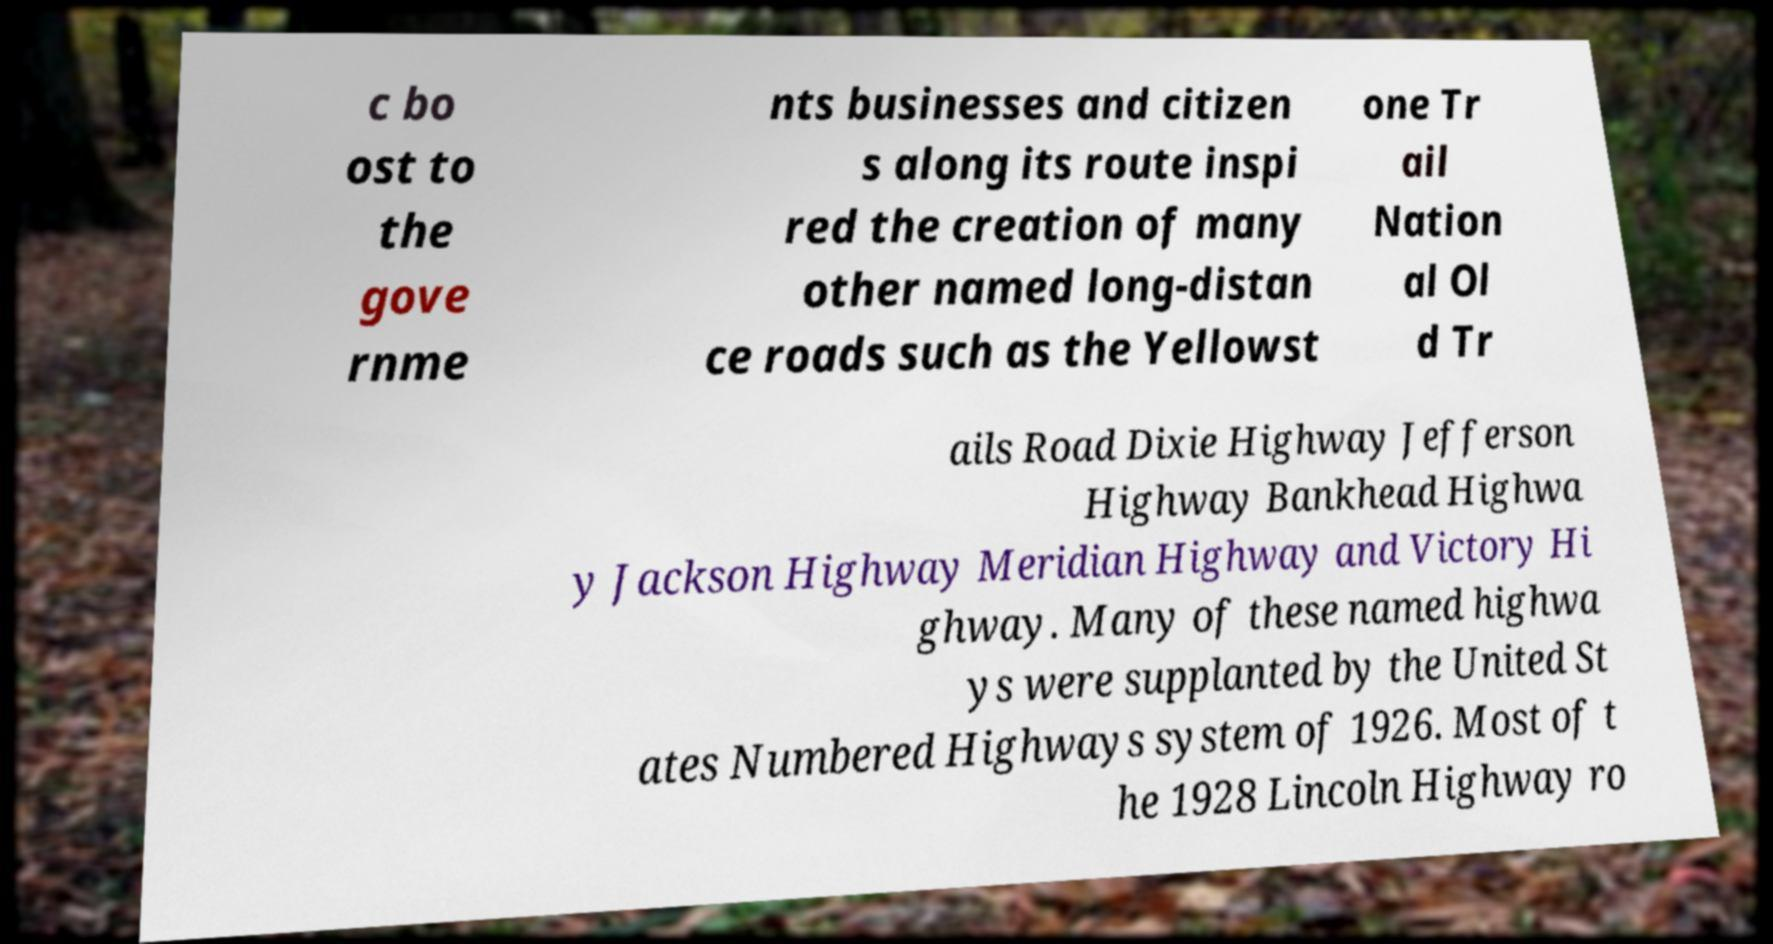Could you extract and type out the text from this image? c bo ost to the gove rnme nts businesses and citizen s along its route inspi red the creation of many other named long-distan ce roads such as the Yellowst one Tr ail Nation al Ol d Tr ails Road Dixie Highway Jefferson Highway Bankhead Highwa y Jackson Highway Meridian Highway and Victory Hi ghway. Many of these named highwa ys were supplanted by the United St ates Numbered Highways system of 1926. Most of t he 1928 Lincoln Highway ro 